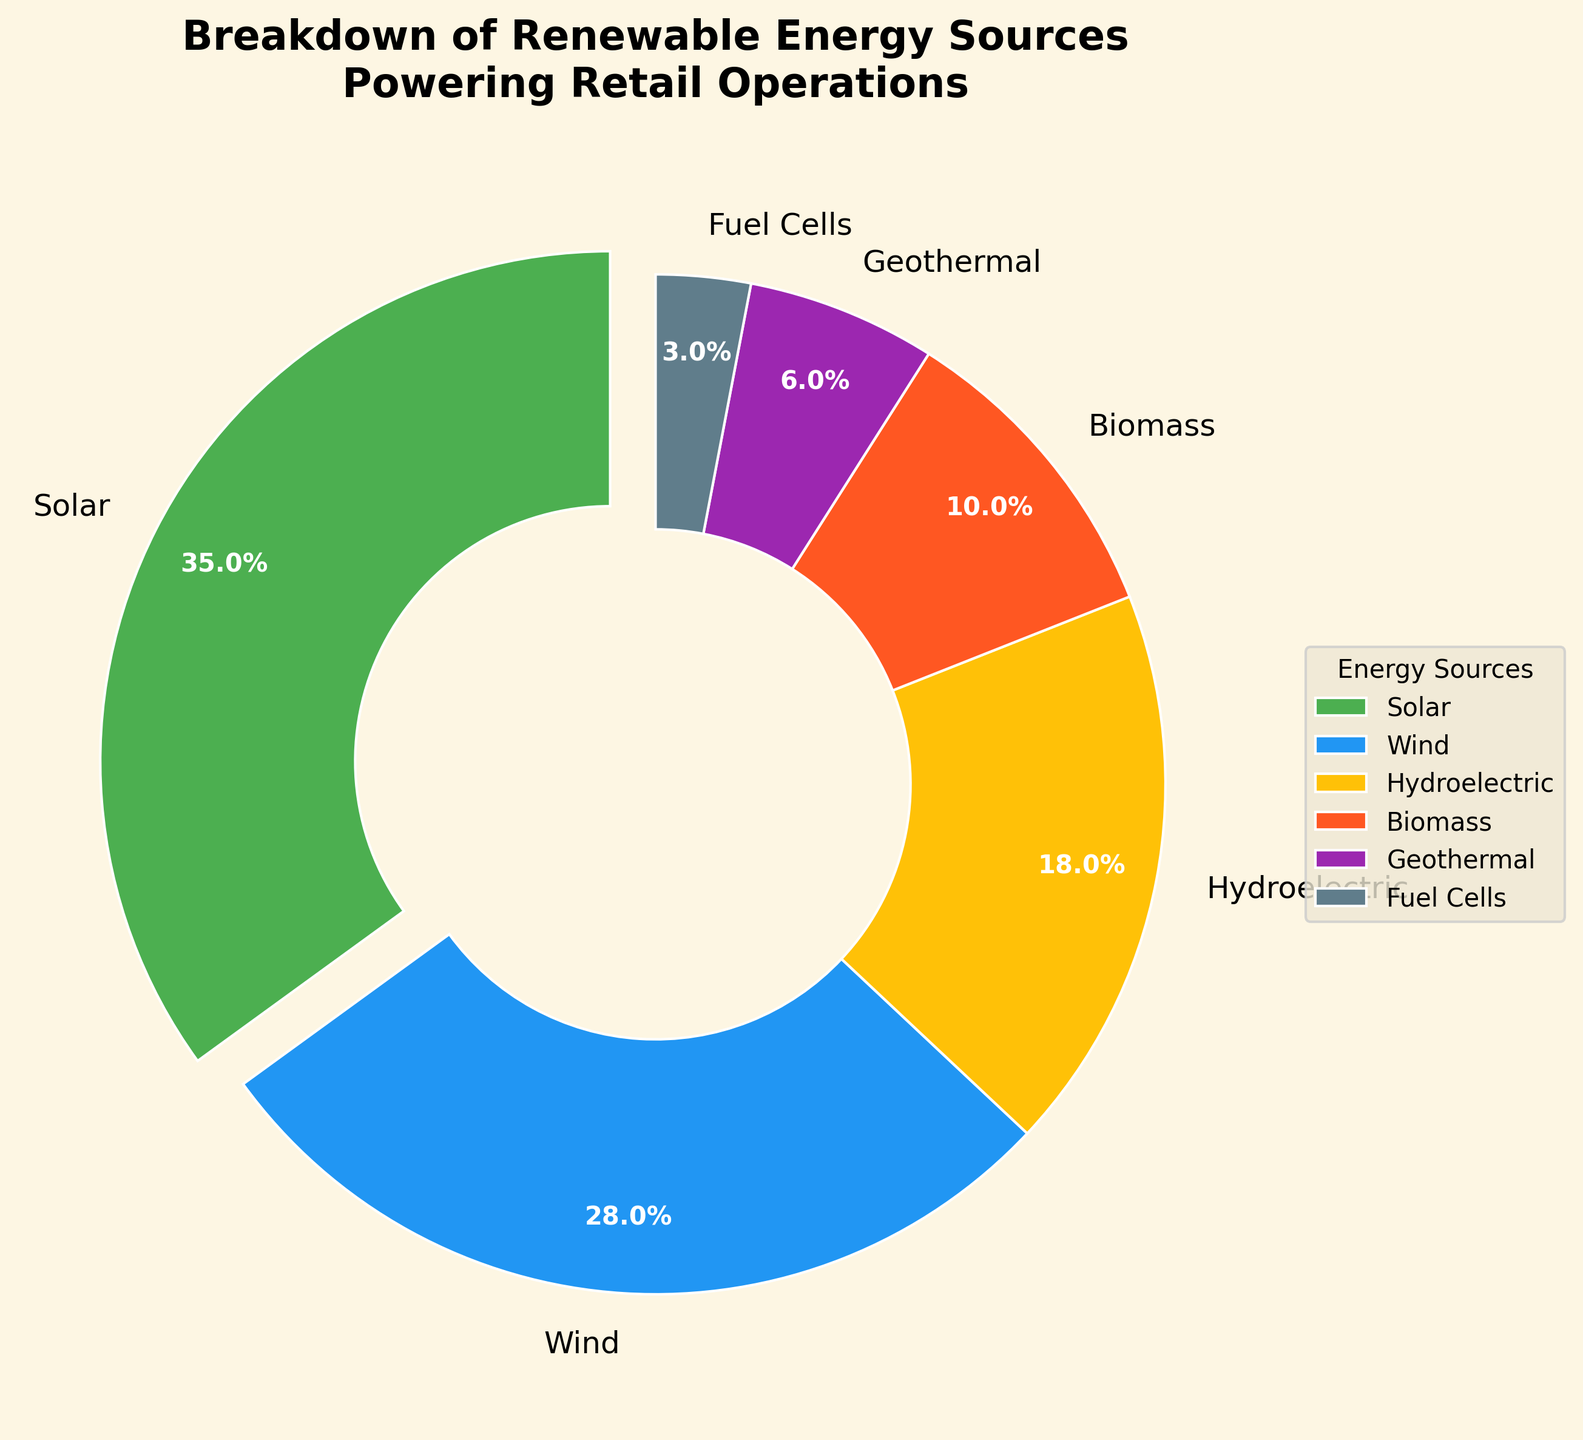what percentage of the energy sources are from wind and solar combined? The percentages for Wind and Solar are 28% and 35%, respectively. Adding these, 28 + 35 = 63%.
Answer: 63% how much greater is the contribution of solar energy compared to geothermal energy? The percentage for Solar is 35%, and for Geothermal, it is 6%. The difference is 35 - 6 = 29%.
Answer: 29% what is the smallest energy source, and what is its percentage? The smallest segment in the pie chart is Fuel Cells with a percentage of 3%.
Answer: Fuel Cells, 3% how do biomass and hydroelectric energy sources compare in terms of percentage? Biomass accounts for 10%, while Hydroelectric accounts for 18%. Comparing these, Hydroelectric has a higher percentage.
Answer: Hydroelectric is greater which energy source is represented by the color blue in the chart? The chart style uses a unique color for each energy source. The blue color corresponds to Wind Energy.
Answer: Wind if geothermal and biomass energy contributions are combined, what percentage of the total renewable energy do they represent? The percentages for Geothermal and Biomass are 6% and 10%, respectively. Adding these, 6 + 10 = 16%.
Answer: 16% is the percentage of wind energy less than or greater than the combined percentage of biomass and fuel cells? Wind energy is 28%, while the combined percentage of Biomass (10%) and Fuel Cells (3%) is 13%. Hence, Wind energy is greater.
Answer: Wind is greater which two energy sources have the closest percentages, and what are they? Wind (28%) and Hydroelectric (18%) are close, but Solar (35%) and Wind (28%) have the closest percentages. The difference is 35 - 28 = 7%.
Answer: Solar and Wind which energy source has a significantly larger segment compared to fuel cells, and how much larger is it? Solar is significantly larger than Fuel Cells, with Solar at 35% and Fuel Cells at 3%. The difference is 35 - 3 = 32%.
Answer: Solar, 32% how many energy sources have a percentage greater than 20%? According to the chart, only Solar (35%) and Wind (28%) have percentages greater than 20%.
Answer: 2 